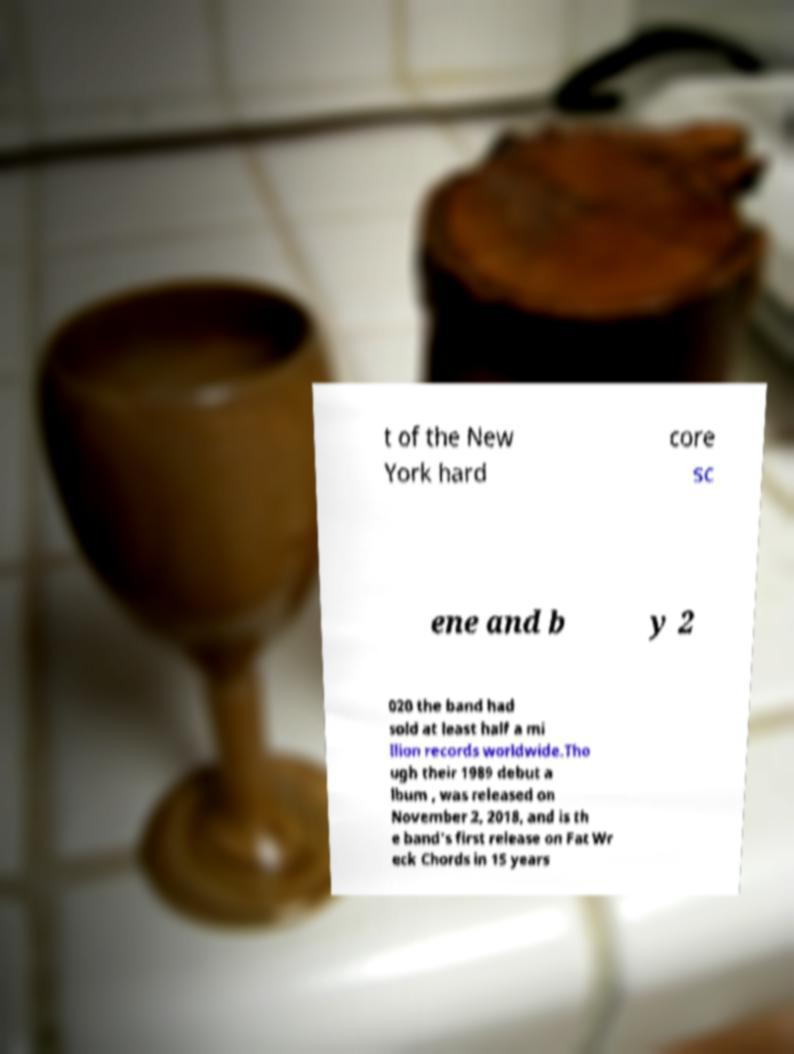Can you read and provide the text displayed in the image?This photo seems to have some interesting text. Can you extract and type it out for me? t of the New York hard core sc ene and b y 2 020 the band had sold at least half a mi llion records worldwide.Tho ugh their 1989 debut a lbum , was released on November 2, 2018, and is th e band's first release on Fat Wr eck Chords in 15 years 